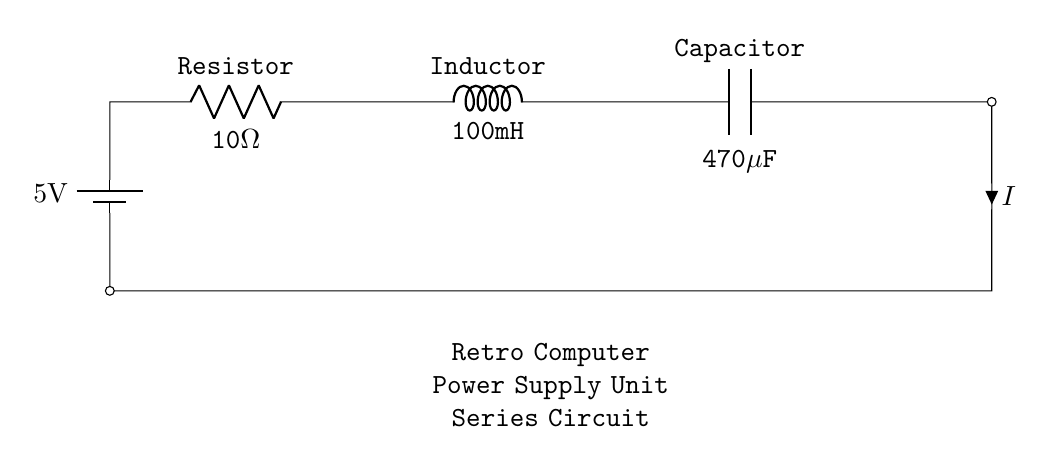What is the total resistance in the circuit? In a series circuit, the total resistance is the sum of all individual resistances. Here, we only have one resistor with a value of 10 ohms. Therefore, the total resistance is equal to this single resistor value.
Answer: 10 ohms What is the value of the capacitor? The capacitor in this circuit is labeled with its capacitance value as 470 microfarads. This is directly observable in the diagram.
Answer: 470 microfarads What is the inductance value? The inductor in the circuit is shown with a value of 100 millihenries. This information is explicitly indicated next to the inductor symbol in the diagram.
Answer: 100 millihenries What is the expected current flow in the circuit if the battery voltage is 5 volts? To find the current (I) in a series circuit, Ohm’s law is applied: I = V/R. Here, the voltage (V) is 5 volts and the resistance (R) is 10 ohms. By substituting these values, the calculation gives I = 5V / 10Ω = 0.5A.
Answer: 0.5 amps What type of circuit configuration is depicted here? The circuit shows components connected in a sequence, with the current flowing through each component one after another. This configuration describes a series circuit.
Answer: Series circuit 